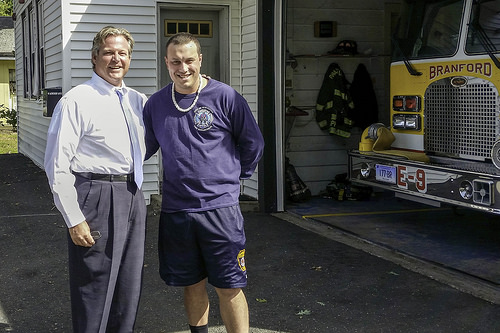<image>
Is the man on the man? No. The man is not positioned on the man. They may be near each other, but the man is not supported by or resting on top of the man. 